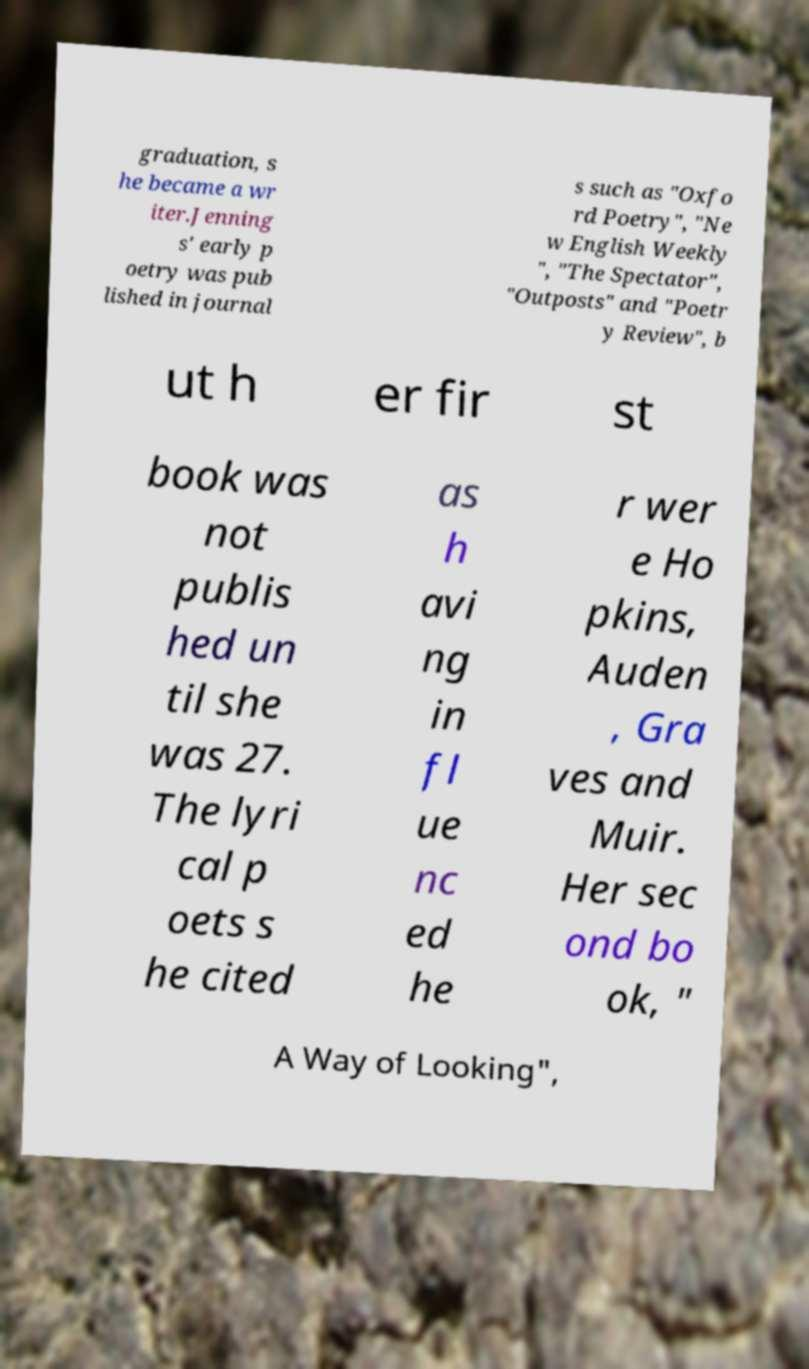Can you read and provide the text displayed in the image?This photo seems to have some interesting text. Can you extract and type it out for me? graduation, s he became a wr iter.Jenning s' early p oetry was pub lished in journal s such as "Oxfo rd Poetry", "Ne w English Weekly ", "The Spectator", "Outposts" and "Poetr y Review", b ut h er fir st book was not publis hed un til she was 27. The lyri cal p oets s he cited as h avi ng in fl ue nc ed he r wer e Ho pkins, Auden , Gra ves and Muir. Her sec ond bo ok, " A Way of Looking", 